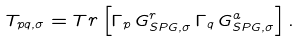<formula> <loc_0><loc_0><loc_500><loc_500>T _ { p q , \sigma } = { T r } \left [ \Gamma _ { p } \, G _ { S P G , \sigma } ^ { r } \, \Gamma _ { q } \, G _ { S P G , \sigma } ^ { a } \right ] .</formula> 